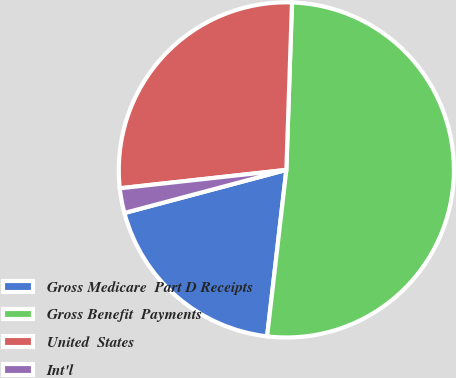Convert chart. <chart><loc_0><loc_0><loc_500><loc_500><pie_chart><fcel>Gross Medicare  Part D Receipts<fcel>Gross Benefit  Payments<fcel>United  States<fcel>Int'l<nl><fcel>19.03%<fcel>51.3%<fcel>27.29%<fcel>2.39%<nl></chart> 